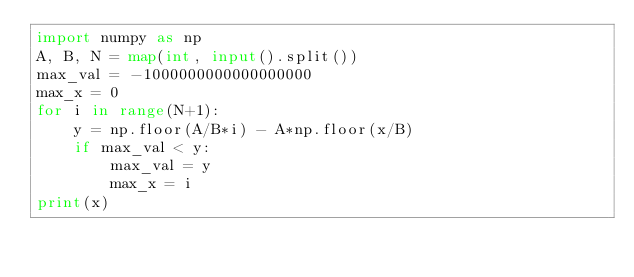<code> <loc_0><loc_0><loc_500><loc_500><_Python_>import numpy as np
A, B, N = map(int, input().split())
max_val = -1000000000000000000
max_x = 0
for i in range(N+1):
    y = np.floor(A/B*i) - A*np.floor(x/B)
    if max_val < y:
        max_val = y
        max_x = i
print(x)</code> 